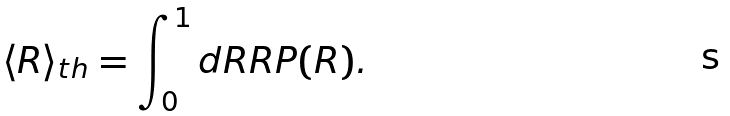<formula> <loc_0><loc_0><loc_500><loc_500>\langle R \rangle _ { t h } = \int _ { 0 } ^ { 1 } d R R P ( R ) .</formula> 